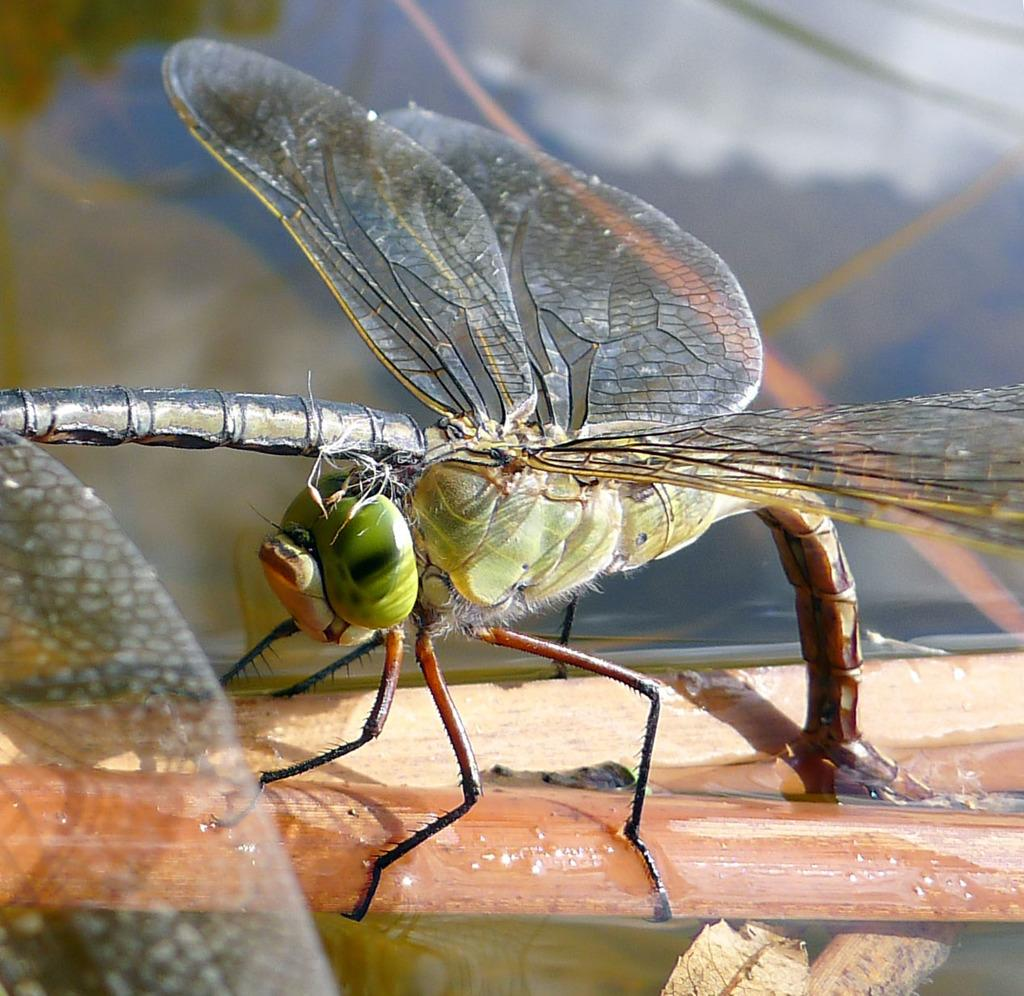What type of creature can be seen in the image? There is an insect in the image. What is the insect sitting on? The insect is on a wooden object. Can you describe the background of the image? The background of the image is blurred. What type of ball is visible on the tray in the image? There is no ball or tray present in the image; it only features an insect on a wooden object with a blurred background. 